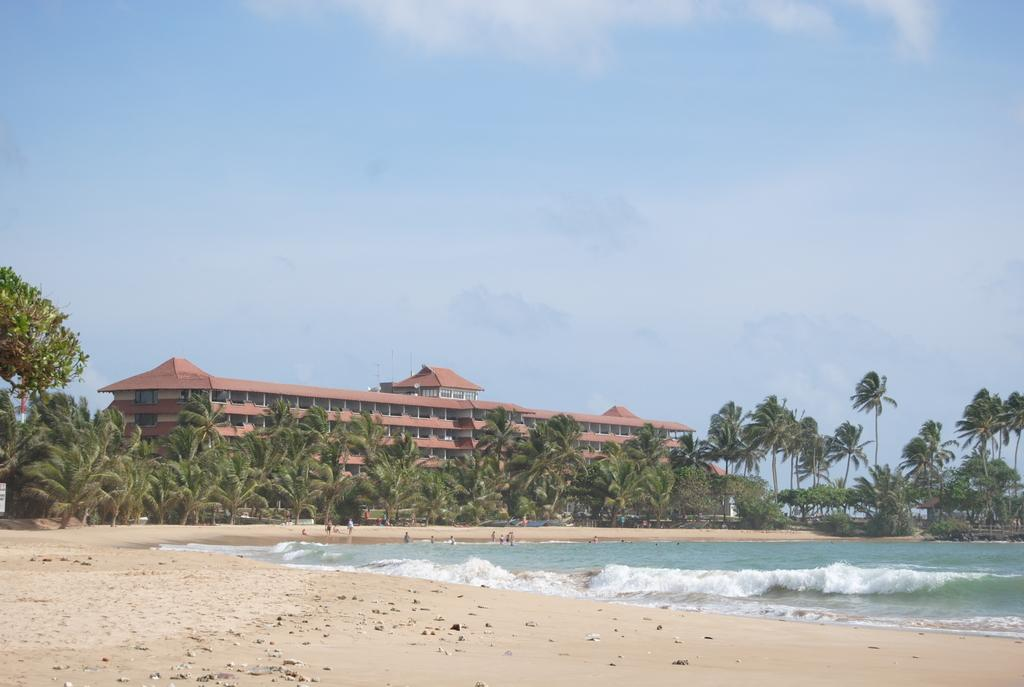What type of location is depicted in the image? The image depicts a beach. What can be seen on the right side of the image? There is water visible on the right side of the image. What is happening near the water in the image? There are people present near the water in the image. What can be seen in the background of the image? There are many trees and a building in the background of the image. What is visible at the top of the image? The sky is visible at the top of the image. What type of bell can be heard ringing in the image? There is no bell present in the image, so it is not possible to hear it ringing. 